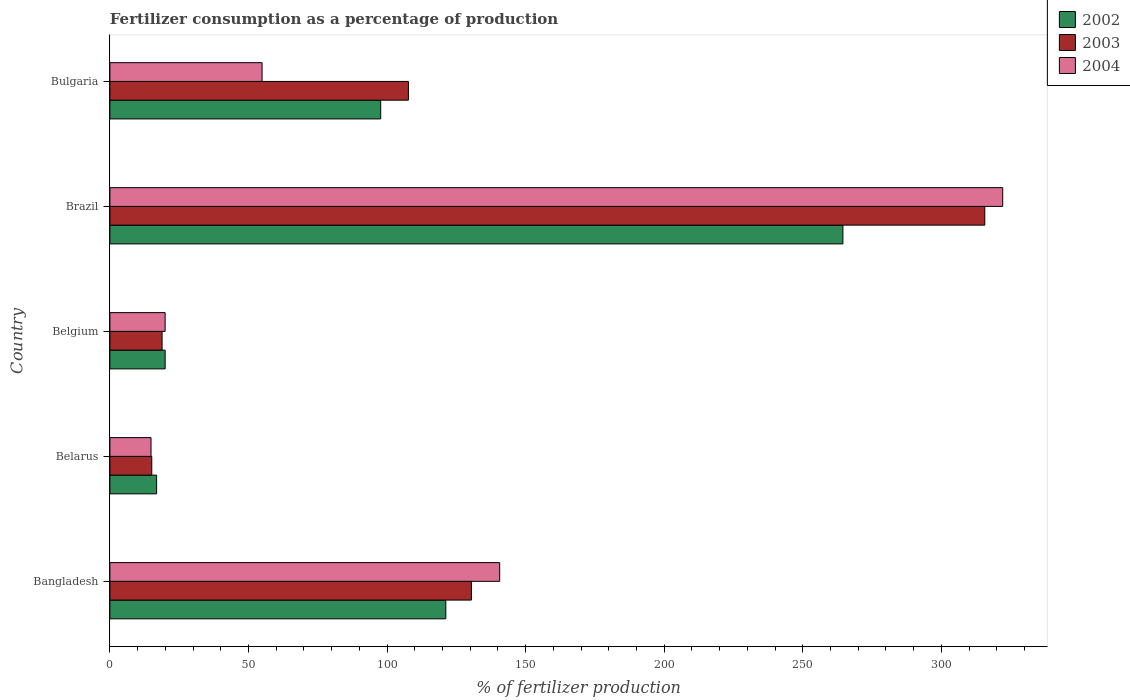Are the number of bars per tick equal to the number of legend labels?
Offer a very short reply. Yes. What is the label of the 3rd group of bars from the top?
Your answer should be compact. Belgium. What is the percentage of fertilizers consumed in 2004 in Bangladesh?
Keep it short and to the point. 140.64. Across all countries, what is the maximum percentage of fertilizers consumed in 2003?
Make the answer very short. 315.68. Across all countries, what is the minimum percentage of fertilizers consumed in 2002?
Provide a succinct answer. 16.86. In which country was the percentage of fertilizers consumed in 2002 minimum?
Provide a short and direct response. Belarus. What is the total percentage of fertilizers consumed in 2003 in the graph?
Make the answer very short. 587.78. What is the difference between the percentage of fertilizers consumed in 2003 in Belgium and that in Brazil?
Offer a very short reply. -296.85. What is the difference between the percentage of fertilizers consumed in 2002 in Bangladesh and the percentage of fertilizers consumed in 2004 in Belarus?
Make the answer very short. 106.37. What is the average percentage of fertilizers consumed in 2004 per country?
Provide a succinct answer. 110.5. What is the difference between the percentage of fertilizers consumed in 2003 and percentage of fertilizers consumed in 2002 in Bangladesh?
Keep it short and to the point. 9.23. What is the ratio of the percentage of fertilizers consumed in 2004 in Bangladesh to that in Bulgaria?
Keep it short and to the point. 2.56. Is the percentage of fertilizers consumed in 2003 in Belgium less than that in Brazil?
Give a very brief answer. Yes. Is the difference between the percentage of fertilizers consumed in 2003 in Brazil and Bulgaria greater than the difference between the percentage of fertilizers consumed in 2002 in Brazil and Bulgaria?
Your answer should be very brief. Yes. What is the difference between the highest and the second highest percentage of fertilizers consumed in 2003?
Your response must be concise. 185.24. What is the difference between the highest and the lowest percentage of fertilizers consumed in 2002?
Make the answer very short. 247.63. Is the sum of the percentage of fertilizers consumed in 2003 in Bangladesh and Belarus greater than the maximum percentage of fertilizers consumed in 2002 across all countries?
Offer a very short reply. No. What does the 1st bar from the top in Belarus represents?
Make the answer very short. 2004. What does the 1st bar from the bottom in Belarus represents?
Ensure brevity in your answer.  2002. How many bars are there?
Your answer should be compact. 15. Are all the bars in the graph horizontal?
Provide a short and direct response. Yes. How many countries are there in the graph?
Offer a terse response. 5. Are the values on the major ticks of X-axis written in scientific E-notation?
Keep it short and to the point. No. Where does the legend appear in the graph?
Give a very brief answer. Top right. What is the title of the graph?
Your response must be concise. Fertilizer consumption as a percentage of production. What is the label or title of the X-axis?
Keep it short and to the point. % of fertilizer production. What is the % of fertilizer production of 2002 in Bangladesh?
Offer a terse response. 121.21. What is the % of fertilizer production in 2003 in Bangladesh?
Ensure brevity in your answer.  130.44. What is the % of fertilizer production in 2004 in Bangladesh?
Provide a succinct answer. 140.64. What is the % of fertilizer production in 2002 in Belarus?
Give a very brief answer. 16.86. What is the % of fertilizer production of 2003 in Belarus?
Keep it short and to the point. 15.11. What is the % of fertilizer production of 2004 in Belarus?
Provide a succinct answer. 14.84. What is the % of fertilizer production of 2002 in Belgium?
Your answer should be very brief. 19.94. What is the % of fertilizer production of 2003 in Belgium?
Provide a succinct answer. 18.83. What is the % of fertilizer production of 2004 in Belgium?
Provide a succinct answer. 19.93. What is the % of fertilizer production of 2002 in Brazil?
Make the answer very short. 264.49. What is the % of fertilizer production in 2003 in Brazil?
Offer a terse response. 315.68. What is the % of fertilizer production of 2004 in Brazil?
Offer a terse response. 322.16. What is the % of fertilizer production of 2002 in Bulgaria?
Your answer should be compact. 97.71. What is the % of fertilizer production of 2003 in Bulgaria?
Your response must be concise. 107.72. What is the % of fertilizer production of 2004 in Bulgaria?
Give a very brief answer. 54.91. Across all countries, what is the maximum % of fertilizer production in 2002?
Your answer should be compact. 264.49. Across all countries, what is the maximum % of fertilizer production of 2003?
Make the answer very short. 315.68. Across all countries, what is the maximum % of fertilizer production of 2004?
Offer a very short reply. 322.16. Across all countries, what is the minimum % of fertilizer production of 2002?
Your response must be concise. 16.86. Across all countries, what is the minimum % of fertilizer production in 2003?
Offer a very short reply. 15.11. Across all countries, what is the minimum % of fertilizer production of 2004?
Give a very brief answer. 14.84. What is the total % of fertilizer production of 2002 in the graph?
Keep it short and to the point. 520.21. What is the total % of fertilizer production in 2003 in the graph?
Your response must be concise. 587.78. What is the total % of fertilizer production of 2004 in the graph?
Keep it short and to the point. 552.49. What is the difference between the % of fertilizer production in 2002 in Bangladesh and that in Belarus?
Your answer should be compact. 104.35. What is the difference between the % of fertilizer production in 2003 in Bangladesh and that in Belarus?
Provide a short and direct response. 115.33. What is the difference between the % of fertilizer production in 2004 in Bangladesh and that in Belarus?
Provide a succinct answer. 125.8. What is the difference between the % of fertilizer production of 2002 in Bangladesh and that in Belgium?
Ensure brevity in your answer.  101.27. What is the difference between the % of fertilizer production in 2003 in Bangladesh and that in Belgium?
Ensure brevity in your answer.  111.61. What is the difference between the % of fertilizer production in 2004 in Bangladesh and that in Belgium?
Ensure brevity in your answer.  120.71. What is the difference between the % of fertilizer production of 2002 in Bangladesh and that in Brazil?
Give a very brief answer. -143.28. What is the difference between the % of fertilizer production in 2003 in Bangladesh and that in Brazil?
Give a very brief answer. -185.24. What is the difference between the % of fertilizer production of 2004 in Bangladesh and that in Brazil?
Provide a succinct answer. -181.52. What is the difference between the % of fertilizer production in 2002 in Bangladesh and that in Bulgaria?
Give a very brief answer. 23.5. What is the difference between the % of fertilizer production of 2003 in Bangladesh and that in Bulgaria?
Provide a succinct answer. 22.73. What is the difference between the % of fertilizer production in 2004 in Bangladesh and that in Bulgaria?
Ensure brevity in your answer.  85.73. What is the difference between the % of fertilizer production in 2002 in Belarus and that in Belgium?
Provide a succinct answer. -3.08. What is the difference between the % of fertilizer production of 2003 in Belarus and that in Belgium?
Give a very brief answer. -3.72. What is the difference between the % of fertilizer production in 2004 in Belarus and that in Belgium?
Your response must be concise. -5.09. What is the difference between the % of fertilizer production of 2002 in Belarus and that in Brazil?
Offer a terse response. -247.63. What is the difference between the % of fertilizer production in 2003 in Belarus and that in Brazil?
Make the answer very short. -300.57. What is the difference between the % of fertilizer production of 2004 in Belarus and that in Brazil?
Give a very brief answer. -307.31. What is the difference between the % of fertilizer production of 2002 in Belarus and that in Bulgaria?
Provide a short and direct response. -80.85. What is the difference between the % of fertilizer production in 2003 in Belarus and that in Bulgaria?
Your response must be concise. -92.61. What is the difference between the % of fertilizer production of 2004 in Belarus and that in Bulgaria?
Provide a succinct answer. -40.07. What is the difference between the % of fertilizer production in 2002 in Belgium and that in Brazil?
Make the answer very short. -244.55. What is the difference between the % of fertilizer production of 2003 in Belgium and that in Brazil?
Ensure brevity in your answer.  -296.85. What is the difference between the % of fertilizer production in 2004 in Belgium and that in Brazil?
Make the answer very short. -302.23. What is the difference between the % of fertilizer production of 2002 in Belgium and that in Bulgaria?
Give a very brief answer. -77.77. What is the difference between the % of fertilizer production of 2003 in Belgium and that in Bulgaria?
Provide a short and direct response. -88.89. What is the difference between the % of fertilizer production in 2004 in Belgium and that in Bulgaria?
Your answer should be very brief. -34.98. What is the difference between the % of fertilizer production in 2002 in Brazil and that in Bulgaria?
Give a very brief answer. 166.78. What is the difference between the % of fertilizer production in 2003 in Brazil and that in Bulgaria?
Provide a succinct answer. 207.97. What is the difference between the % of fertilizer production of 2004 in Brazil and that in Bulgaria?
Make the answer very short. 267.25. What is the difference between the % of fertilizer production of 2002 in Bangladesh and the % of fertilizer production of 2003 in Belarus?
Provide a succinct answer. 106.1. What is the difference between the % of fertilizer production of 2002 in Bangladesh and the % of fertilizer production of 2004 in Belarus?
Offer a very short reply. 106.37. What is the difference between the % of fertilizer production of 2003 in Bangladesh and the % of fertilizer production of 2004 in Belarus?
Provide a succinct answer. 115.6. What is the difference between the % of fertilizer production of 2002 in Bangladesh and the % of fertilizer production of 2003 in Belgium?
Your answer should be compact. 102.38. What is the difference between the % of fertilizer production of 2002 in Bangladesh and the % of fertilizer production of 2004 in Belgium?
Give a very brief answer. 101.28. What is the difference between the % of fertilizer production of 2003 in Bangladesh and the % of fertilizer production of 2004 in Belgium?
Offer a very short reply. 110.51. What is the difference between the % of fertilizer production of 2002 in Bangladesh and the % of fertilizer production of 2003 in Brazil?
Offer a very short reply. -194.47. What is the difference between the % of fertilizer production in 2002 in Bangladesh and the % of fertilizer production in 2004 in Brazil?
Offer a very short reply. -200.95. What is the difference between the % of fertilizer production in 2003 in Bangladesh and the % of fertilizer production in 2004 in Brazil?
Offer a very short reply. -191.72. What is the difference between the % of fertilizer production in 2002 in Bangladesh and the % of fertilizer production in 2003 in Bulgaria?
Provide a succinct answer. 13.5. What is the difference between the % of fertilizer production of 2002 in Bangladesh and the % of fertilizer production of 2004 in Bulgaria?
Your response must be concise. 66.3. What is the difference between the % of fertilizer production in 2003 in Bangladesh and the % of fertilizer production in 2004 in Bulgaria?
Provide a succinct answer. 75.53. What is the difference between the % of fertilizer production in 2002 in Belarus and the % of fertilizer production in 2003 in Belgium?
Give a very brief answer. -1.97. What is the difference between the % of fertilizer production of 2002 in Belarus and the % of fertilizer production of 2004 in Belgium?
Keep it short and to the point. -3.07. What is the difference between the % of fertilizer production in 2003 in Belarus and the % of fertilizer production in 2004 in Belgium?
Your answer should be compact. -4.82. What is the difference between the % of fertilizer production in 2002 in Belarus and the % of fertilizer production in 2003 in Brazil?
Ensure brevity in your answer.  -298.83. What is the difference between the % of fertilizer production in 2002 in Belarus and the % of fertilizer production in 2004 in Brazil?
Offer a very short reply. -305.3. What is the difference between the % of fertilizer production in 2003 in Belarus and the % of fertilizer production in 2004 in Brazil?
Your answer should be very brief. -307.05. What is the difference between the % of fertilizer production of 2002 in Belarus and the % of fertilizer production of 2003 in Bulgaria?
Keep it short and to the point. -90.86. What is the difference between the % of fertilizer production of 2002 in Belarus and the % of fertilizer production of 2004 in Bulgaria?
Make the answer very short. -38.05. What is the difference between the % of fertilizer production of 2003 in Belarus and the % of fertilizer production of 2004 in Bulgaria?
Your response must be concise. -39.8. What is the difference between the % of fertilizer production in 2002 in Belgium and the % of fertilizer production in 2003 in Brazil?
Provide a succinct answer. -295.74. What is the difference between the % of fertilizer production of 2002 in Belgium and the % of fertilizer production of 2004 in Brazil?
Ensure brevity in your answer.  -302.22. What is the difference between the % of fertilizer production in 2003 in Belgium and the % of fertilizer production in 2004 in Brazil?
Your response must be concise. -303.33. What is the difference between the % of fertilizer production in 2002 in Belgium and the % of fertilizer production in 2003 in Bulgaria?
Your answer should be very brief. -87.78. What is the difference between the % of fertilizer production of 2002 in Belgium and the % of fertilizer production of 2004 in Bulgaria?
Provide a succinct answer. -34.97. What is the difference between the % of fertilizer production of 2003 in Belgium and the % of fertilizer production of 2004 in Bulgaria?
Provide a short and direct response. -36.08. What is the difference between the % of fertilizer production in 2002 in Brazil and the % of fertilizer production in 2003 in Bulgaria?
Your answer should be very brief. 156.77. What is the difference between the % of fertilizer production in 2002 in Brazil and the % of fertilizer production in 2004 in Bulgaria?
Ensure brevity in your answer.  209.58. What is the difference between the % of fertilizer production in 2003 in Brazil and the % of fertilizer production in 2004 in Bulgaria?
Give a very brief answer. 260.77. What is the average % of fertilizer production of 2002 per country?
Your response must be concise. 104.04. What is the average % of fertilizer production of 2003 per country?
Give a very brief answer. 117.56. What is the average % of fertilizer production of 2004 per country?
Provide a short and direct response. 110.5. What is the difference between the % of fertilizer production of 2002 and % of fertilizer production of 2003 in Bangladesh?
Offer a very short reply. -9.23. What is the difference between the % of fertilizer production in 2002 and % of fertilizer production in 2004 in Bangladesh?
Ensure brevity in your answer.  -19.43. What is the difference between the % of fertilizer production of 2003 and % of fertilizer production of 2004 in Bangladesh?
Offer a very short reply. -10.2. What is the difference between the % of fertilizer production in 2002 and % of fertilizer production in 2003 in Belarus?
Your answer should be very brief. 1.75. What is the difference between the % of fertilizer production in 2002 and % of fertilizer production in 2004 in Belarus?
Provide a short and direct response. 2.01. What is the difference between the % of fertilizer production in 2003 and % of fertilizer production in 2004 in Belarus?
Give a very brief answer. 0.27. What is the difference between the % of fertilizer production in 2002 and % of fertilizer production in 2003 in Belgium?
Provide a short and direct response. 1.11. What is the difference between the % of fertilizer production of 2002 and % of fertilizer production of 2004 in Belgium?
Ensure brevity in your answer.  0.01. What is the difference between the % of fertilizer production of 2003 and % of fertilizer production of 2004 in Belgium?
Your response must be concise. -1.1. What is the difference between the % of fertilizer production of 2002 and % of fertilizer production of 2003 in Brazil?
Give a very brief answer. -51.19. What is the difference between the % of fertilizer production of 2002 and % of fertilizer production of 2004 in Brazil?
Give a very brief answer. -57.67. What is the difference between the % of fertilizer production of 2003 and % of fertilizer production of 2004 in Brazil?
Offer a terse response. -6.47. What is the difference between the % of fertilizer production in 2002 and % of fertilizer production in 2003 in Bulgaria?
Your answer should be compact. -10.01. What is the difference between the % of fertilizer production in 2002 and % of fertilizer production in 2004 in Bulgaria?
Your answer should be compact. 42.8. What is the difference between the % of fertilizer production of 2003 and % of fertilizer production of 2004 in Bulgaria?
Offer a very short reply. 52.8. What is the ratio of the % of fertilizer production in 2002 in Bangladesh to that in Belarus?
Your answer should be very brief. 7.19. What is the ratio of the % of fertilizer production of 2003 in Bangladesh to that in Belarus?
Offer a very short reply. 8.63. What is the ratio of the % of fertilizer production in 2004 in Bangladesh to that in Belarus?
Your answer should be compact. 9.48. What is the ratio of the % of fertilizer production in 2002 in Bangladesh to that in Belgium?
Provide a succinct answer. 6.08. What is the ratio of the % of fertilizer production of 2003 in Bangladesh to that in Belgium?
Provide a short and direct response. 6.93. What is the ratio of the % of fertilizer production in 2004 in Bangladesh to that in Belgium?
Offer a terse response. 7.06. What is the ratio of the % of fertilizer production of 2002 in Bangladesh to that in Brazil?
Provide a short and direct response. 0.46. What is the ratio of the % of fertilizer production of 2003 in Bangladesh to that in Brazil?
Your answer should be compact. 0.41. What is the ratio of the % of fertilizer production of 2004 in Bangladesh to that in Brazil?
Give a very brief answer. 0.44. What is the ratio of the % of fertilizer production in 2002 in Bangladesh to that in Bulgaria?
Provide a succinct answer. 1.24. What is the ratio of the % of fertilizer production in 2003 in Bangladesh to that in Bulgaria?
Provide a short and direct response. 1.21. What is the ratio of the % of fertilizer production in 2004 in Bangladesh to that in Bulgaria?
Your answer should be compact. 2.56. What is the ratio of the % of fertilizer production of 2002 in Belarus to that in Belgium?
Offer a terse response. 0.85. What is the ratio of the % of fertilizer production of 2003 in Belarus to that in Belgium?
Your answer should be very brief. 0.8. What is the ratio of the % of fertilizer production of 2004 in Belarus to that in Belgium?
Make the answer very short. 0.74. What is the ratio of the % of fertilizer production of 2002 in Belarus to that in Brazil?
Provide a succinct answer. 0.06. What is the ratio of the % of fertilizer production in 2003 in Belarus to that in Brazil?
Provide a succinct answer. 0.05. What is the ratio of the % of fertilizer production in 2004 in Belarus to that in Brazil?
Provide a short and direct response. 0.05. What is the ratio of the % of fertilizer production in 2002 in Belarus to that in Bulgaria?
Provide a short and direct response. 0.17. What is the ratio of the % of fertilizer production of 2003 in Belarus to that in Bulgaria?
Your answer should be compact. 0.14. What is the ratio of the % of fertilizer production in 2004 in Belarus to that in Bulgaria?
Ensure brevity in your answer.  0.27. What is the ratio of the % of fertilizer production of 2002 in Belgium to that in Brazil?
Your answer should be very brief. 0.08. What is the ratio of the % of fertilizer production of 2003 in Belgium to that in Brazil?
Make the answer very short. 0.06. What is the ratio of the % of fertilizer production in 2004 in Belgium to that in Brazil?
Give a very brief answer. 0.06. What is the ratio of the % of fertilizer production of 2002 in Belgium to that in Bulgaria?
Keep it short and to the point. 0.2. What is the ratio of the % of fertilizer production in 2003 in Belgium to that in Bulgaria?
Offer a very short reply. 0.17. What is the ratio of the % of fertilizer production of 2004 in Belgium to that in Bulgaria?
Offer a terse response. 0.36. What is the ratio of the % of fertilizer production of 2002 in Brazil to that in Bulgaria?
Provide a short and direct response. 2.71. What is the ratio of the % of fertilizer production in 2003 in Brazil to that in Bulgaria?
Provide a short and direct response. 2.93. What is the ratio of the % of fertilizer production of 2004 in Brazil to that in Bulgaria?
Your answer should be very brief. 5.87. What is the difference between the highest and the second highest % of fertilizer production of 2002?
Your answer should be compact. 143.28. What is the difference between the highest and the second highest % of fertilizer production in 2003?
Keep it short and to the point. 185.24. What is the difference between the highest and the second highest % of fertilizer production in 2004?
Your answer should be compact. 181.52. What is the difference between the highest and the lowest % of fertilizer production of 2002?
Ensure brevity in your answer.  247.63. What is the difference between the highest and the lowest % of fertilizer production of 2003?
Offer a terse response. 300.57. What is the difference between the highest and the lowest % of fertilizer production in 2004?
Your response must be concise. 307.31. 